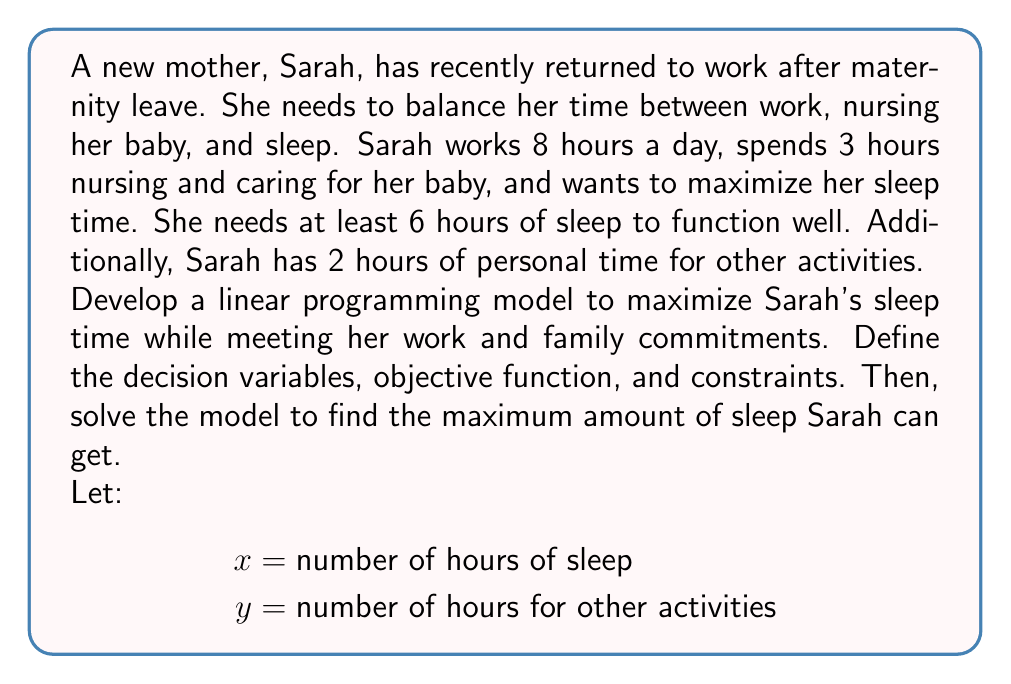Could you help me with this problem? To develop the linear programming model, we'll follow these steps:

1. Define decision variables:
   $x$ = number of hours of sleep
   $y$ = number of hours for other activities

2. Formulate the objective function:
   Maximize $z = x$ (sleep time)

3. Identify constraints:
   a. Total time constraint: $x + y + 8 + 3 = 24$ (24 hours in a day)
   b. Minimum sleep requirement: $x \geq 6$
   c. Minimum personal time: $y \geq 2$
   d. Non-negativity constraints: $x \geq 0, y \geq 0$

4. Write the complete linear programming model:

   Maximize $z = x$
   Subject to:
   $x + y = 13$ (simplifying the total time constraint)
   $x \geq 6$
   $y \geq 2$
   $x \geq 0, y \geq 0$

5. Solve the model:
   From the total time constraint: $y = 13 - x$
   Substituting this into the minimum personal time constraint:
   $13 - x \geq 2$
   $x \leq 11$

   Therefore, the maximum value of $x$ that satisfies all constraints is 11.

6. Check the solution:
   $x = 11$ (sleep time)
   $y = 13 - 11 = 2$ (other activities)
   
   This solution satisfies all constraints:
   - Total time: $11 + 2 + 8 + 3 = 24$
   - Minimum sleep: $11 \geq 6$
   - Minimum personal time: $2 \geq 2$
   - Non-negativity: $11 \geq 0, 2 \geq 0$
Answer: Maximum sleep time: 11 hours 